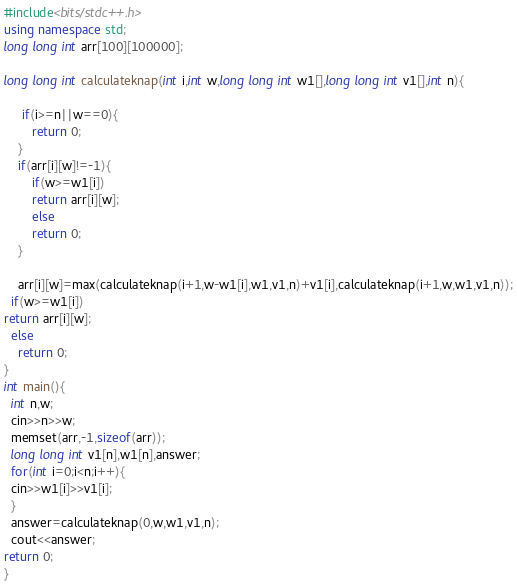<code> <loc_0><loc_0><loc_500><loc_500><_C++_>#include<bits/stdc++.h>
using namespace std;
long long int arr[100][100000];

long long int calculateknap(int i,int w,long long int w1[],long long int v1[],int n){
    
     if(i>=n||w==0){
        return 0;
    }
    if(arr[i][w]!=-1){
        if(w>=w1[i])
        return arr[i][w];
        else 
        return 0;
    }
   
    arr[i][w]=max(calculateknap(i+1,w-w1[i],w1,v1,n)+v1[i],calculateknap(i+1,w,w1,v1,n));
  if(w>=w1[i])
return arr[i][w];
  else
    return 0;
}
int main(){
  int n,w;
  cin>>n>>w;
  memset(arr,-1,sizeof(arr));
  long long int v1[n],w1[n],answer;
  for(int i=0;i<n;i++){
  cin>>w1[i]>>v1[i];
  }
  answer=calculateknap(0,w,w1,v1,n);
  cout<<answer;
return 0;
}</code> 